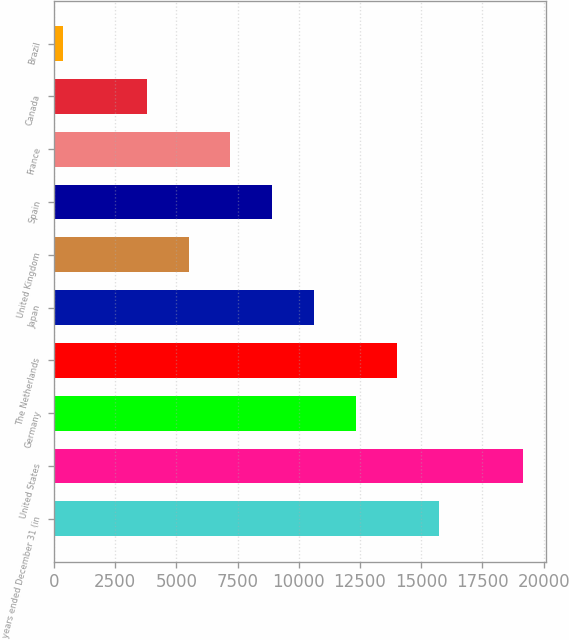Convert chart. <chart><loc_0><loc_0><loc_500><loc_500><bar_chart><fcel>years ended December 31 (in<fcel>United States<fcel>Germany<fcel>The Netherlands<fcel>Japan<fcel>United Kingdom<fcel>Spain<fcel>France<fcel>Canada<fcel>Brazil<nl><fcel>15737.8<fcel>19150.2<fcel>12325.4<fcel>14031.6<fcel>10619.2<fcel>5500.6<fcel>8913<fcel>7206.8<fcel>3794.4<fcel>382<nl></chart> 